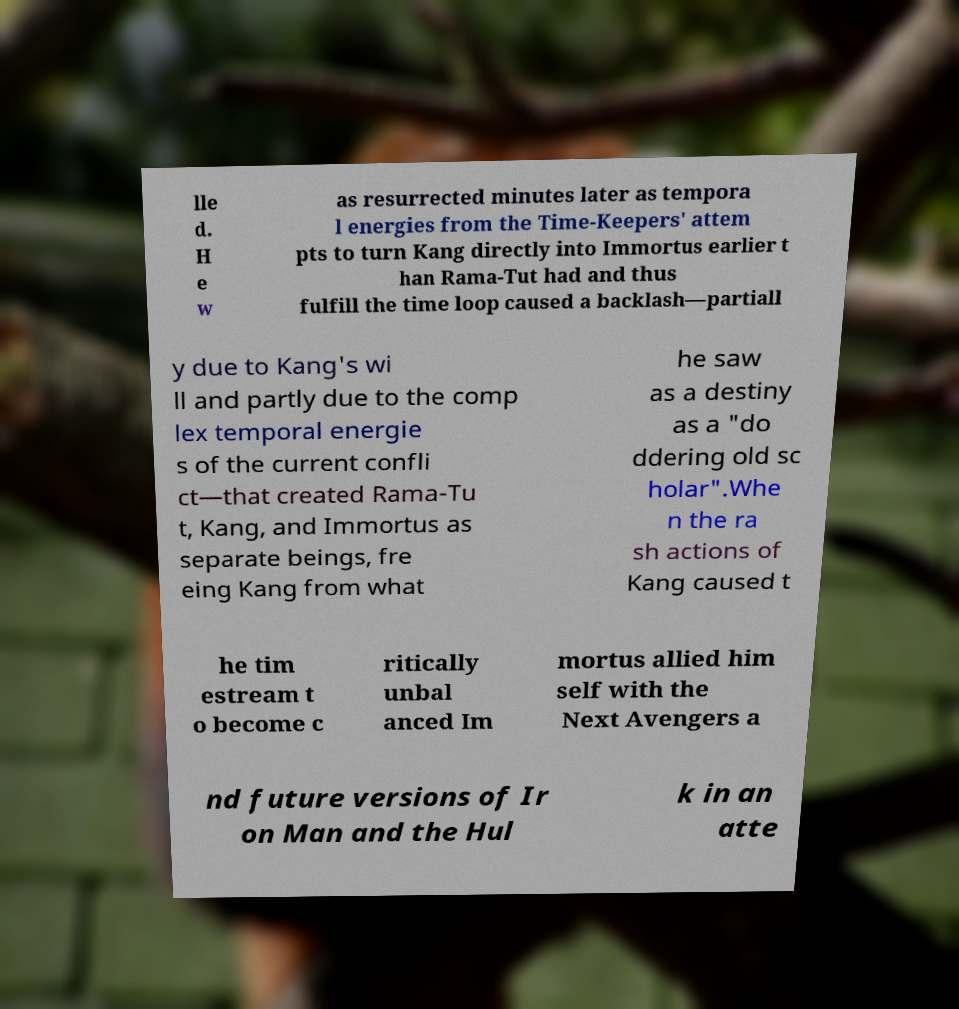What messages or text are displayed in this image? I need them in a readable, typed format. lle d. H e w as resurrected minutes later as tempora l energies from the Time-Keepers' attem pts to turn Kang directly into Immortus earlier t han Rama-Tut had and thus fulfill the time loop caused a backlash—partiall y due to Kang's wi ll and partly due to the comp lex temporal energie s of the current confli ct—that created Rama-Tu t, Kang, and Immortus as separate beings, fre eing Kang from what he saw as a destiny as a "do ddering old sc holar".Whe n the ra sh actions of Kang caused t he tim estream t o become c ritically unbal anced Im mortus allied him self with the Next Avengers a nd future versions of Ir on Man and the Hul k in an atte 